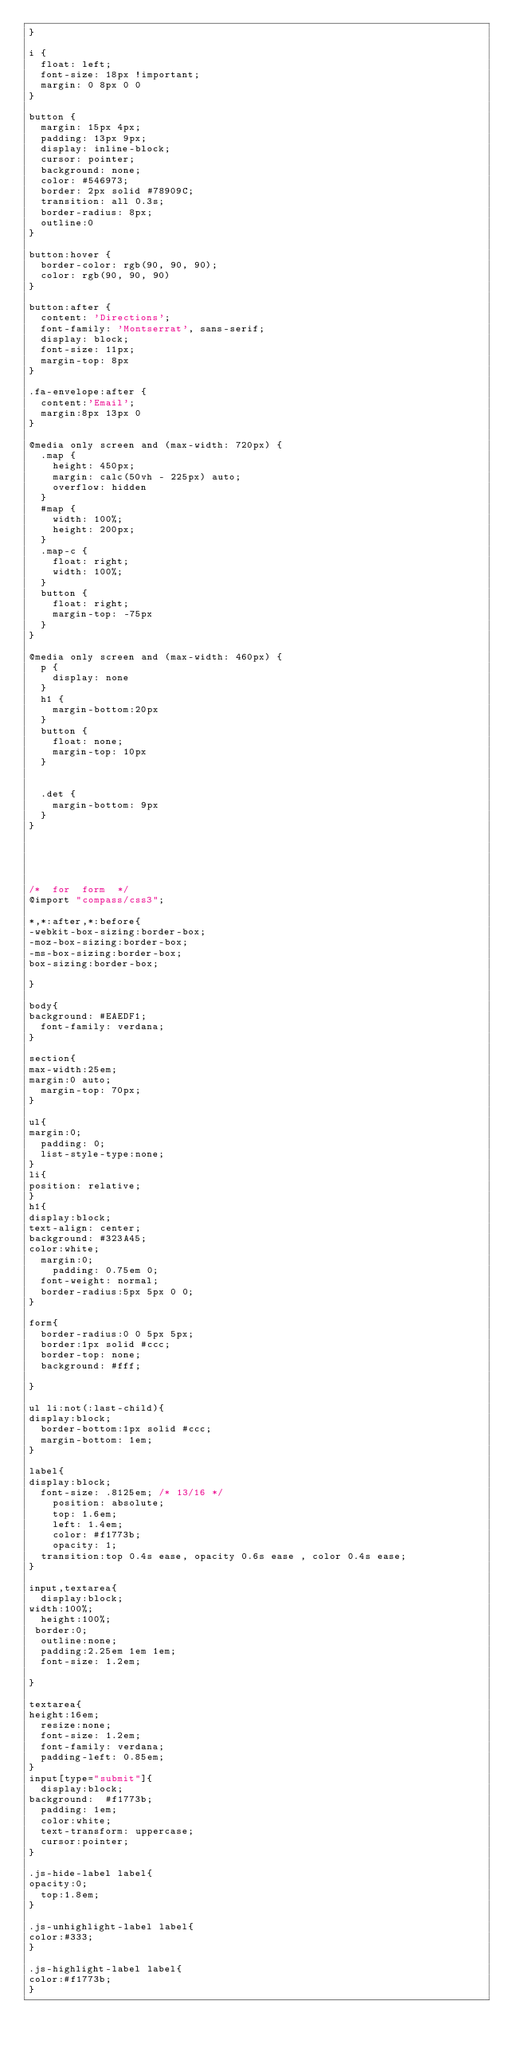Convert code to text. <code><loc_0><loc_0><loc_500><loc_500><_CSS_>}

i {
  float: left;
  font-size: 18px !important;
  margin: 0 8px 0 0
}

button {
  margin: 15px 4px;
  padding: 13px 9px;
  display: inline-block;
  cursor: pointer;
  background: none;
  color: #546973;
  border: 2px solid #78909C;
  transition: all 0.3s;
  border-radius: 8px;
  outline:0
}

button:hover {
  border-color: rgb(90, 90, 90);
  color: rgb(90, 90, 90)
}

button:after {
  content: 'Directions';
  font-family: 'Montserrat', sans-serif;
  display: block;
  font-size: 11px;
  margin-top: 8px
}

.fa-envelope:after {
  content:'Email';
  margin:8px 13px 0
}

@media only screen and (max-width: 720px) {
  .map {
    height: 450px;
    margin: calc(50vh - 225px) auto;
    overflow: hidden
  }
  #map {
    width: 100%;
    height: 200px;
  }
  .map-c {
    float: right;
    width: 100%;
  }
  button {
    float: right;
    margin-top: -75px
  }
}

@media only screen and (max-width: 460px) {
  p {
    display: none
  }
  h1 {
    margin-bottom:20px
  }
  button {
    float: none;
    margin-top: 10px
  }
  
  
  .det {
    margin-bottom: 9px
  }
}





/*  for  form  */
@import "compass/css3";

*,*:after,*:before{
-webkit-box-sizing:border-box;
-moz-box-sizing:border-box;
-ms-box-sizing:border-box;
box-sizing:border-box;

}

body{
background: #EAEDF1;
  font-family: verdana;
}

section{
max-width:25em;
margin:0 auto;
  margin-top: 70px;
}

ul{
margin:0;
  padding: 0;
  list-style-type:none;
}
li{
position: relative;
}
h1{
display:block;
text-align: center;
background: #323A45;
color:white;
  margin:0;
    padding: 0.75em 0;
  font-weight: normal;
  border-radius:5px 5px 0 0;
}

form{
  border-radius:0 0 5px 5px;
  border:1px solid #ccc;
  border-top: none;
  background: #fff;
  
}

ul li:not(:last-child){
display:block;
  border-bottom:1px solid #ccc;
  margin-bottom: 1em;
}

label{
display:block;
  font-size: .8125em; /* 13/16 */
    position: absolute;
    top: 1.6em;
    left: 1.4em;
    color: #f1773b;
    opacity: 1;
  transition:top 0.4s ease, opacity 0.6s ease , color 0.4s ease;
}

input,textarea{
  display:block;
width:100%;
  height:100%;
 border:0;
  outline:none;
  padding:2.25em 1em 1em;
  font-size: 1.2em;
  
}

textarea{
height:16em;
  resize:none;
  font-size: 1.2em;
  font-family: verdana;
  padding-left: 0.85em;
}
input[type="submit"]{
  display:block;
background:  #f1773b;
  padding: 1em;
  color:white;
  text-transform: uppercase;
  cursor:pointer;
}

.js-hide-label label{
opacity:0;
  top:1.8em;
}

.js-unhighlight-label label{
color:#333;
}

.js-highlight-label label{
color:#f1773b;
}

</code> 